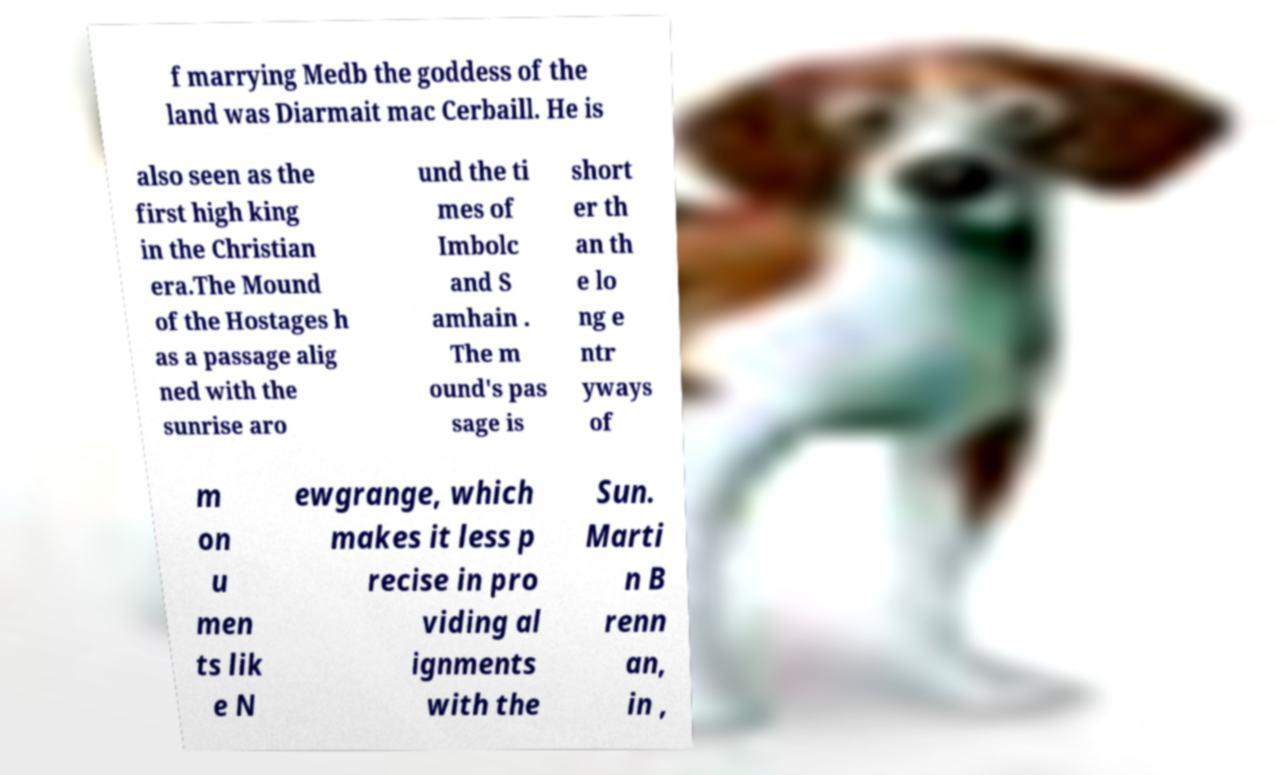I need the written content from this picture converted into text. Can you do that? f marrying Medb the goddess of the land was Diarmait mac Cerbaill. He is also seen as the first high king in the Christian era.The Mound of the Hostages h as a passage alig ned with the sunrise aro und the ti mes of Imbolc and S amhain . The m ound's pas sage is short er th an th e lo ng e ntr yways of m on u men ts lik e N ewgrange, which makes it less p recise in pro viding al ignments with the Sun. Marti n B renn an, in , 